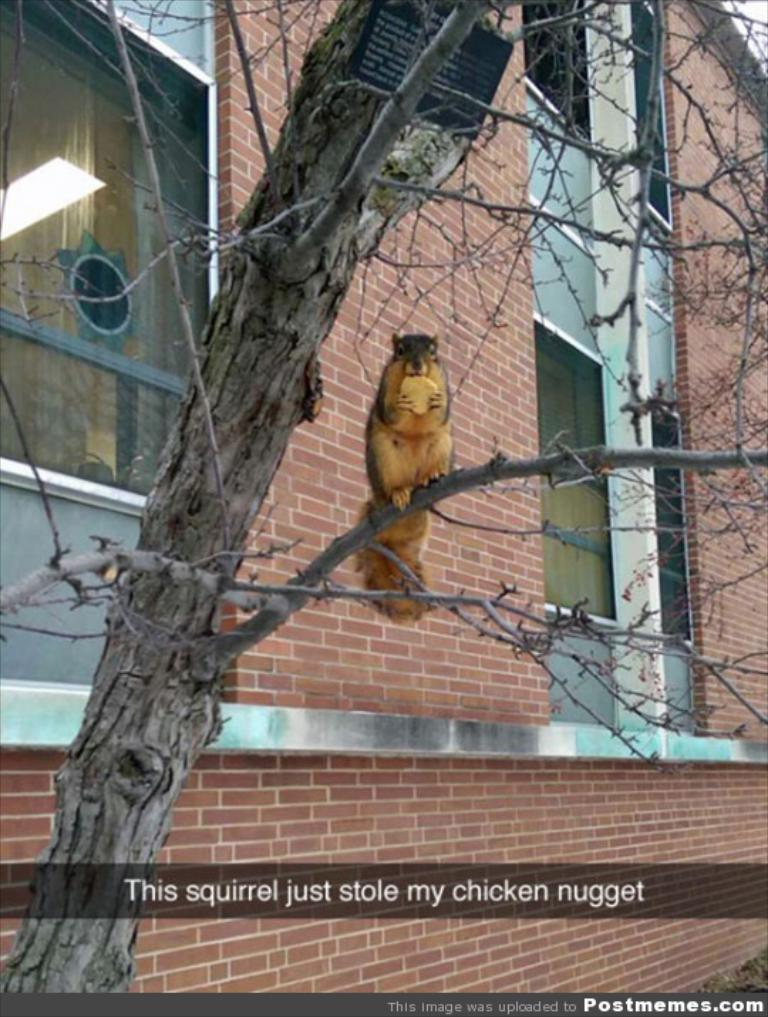What is the main subject of the image? There is an animal sitting on a stem in the image. What can be seen in the background of the image? There is a wall and windows in the background of the image. Is there any text or marking at the bottom of the image? Yes, there is a watermark at the bottom of the image. How is the animal treating its wound in the image? There is no wound visible on the animal in the image. What type of pest can be seen crawling on the wall in the image? There are no pests visible on the wall in the image. 